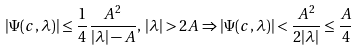Convert formula to latex. <formula><loc_0><loc_0><loc_500><loc_500>| \Psi ( c , \lambda ) | \leq \frac { 1 } { 4 } \frac { A ^ { 2 } } { | \lambda | - A } , \, | \lambda | > 2 A \Rightarrow | \Psi ( c , \lambda ) | < \frac { A ^ { 2 } } { 2 | \lambda | } \leq \frac { A } { 4 }</formula> 